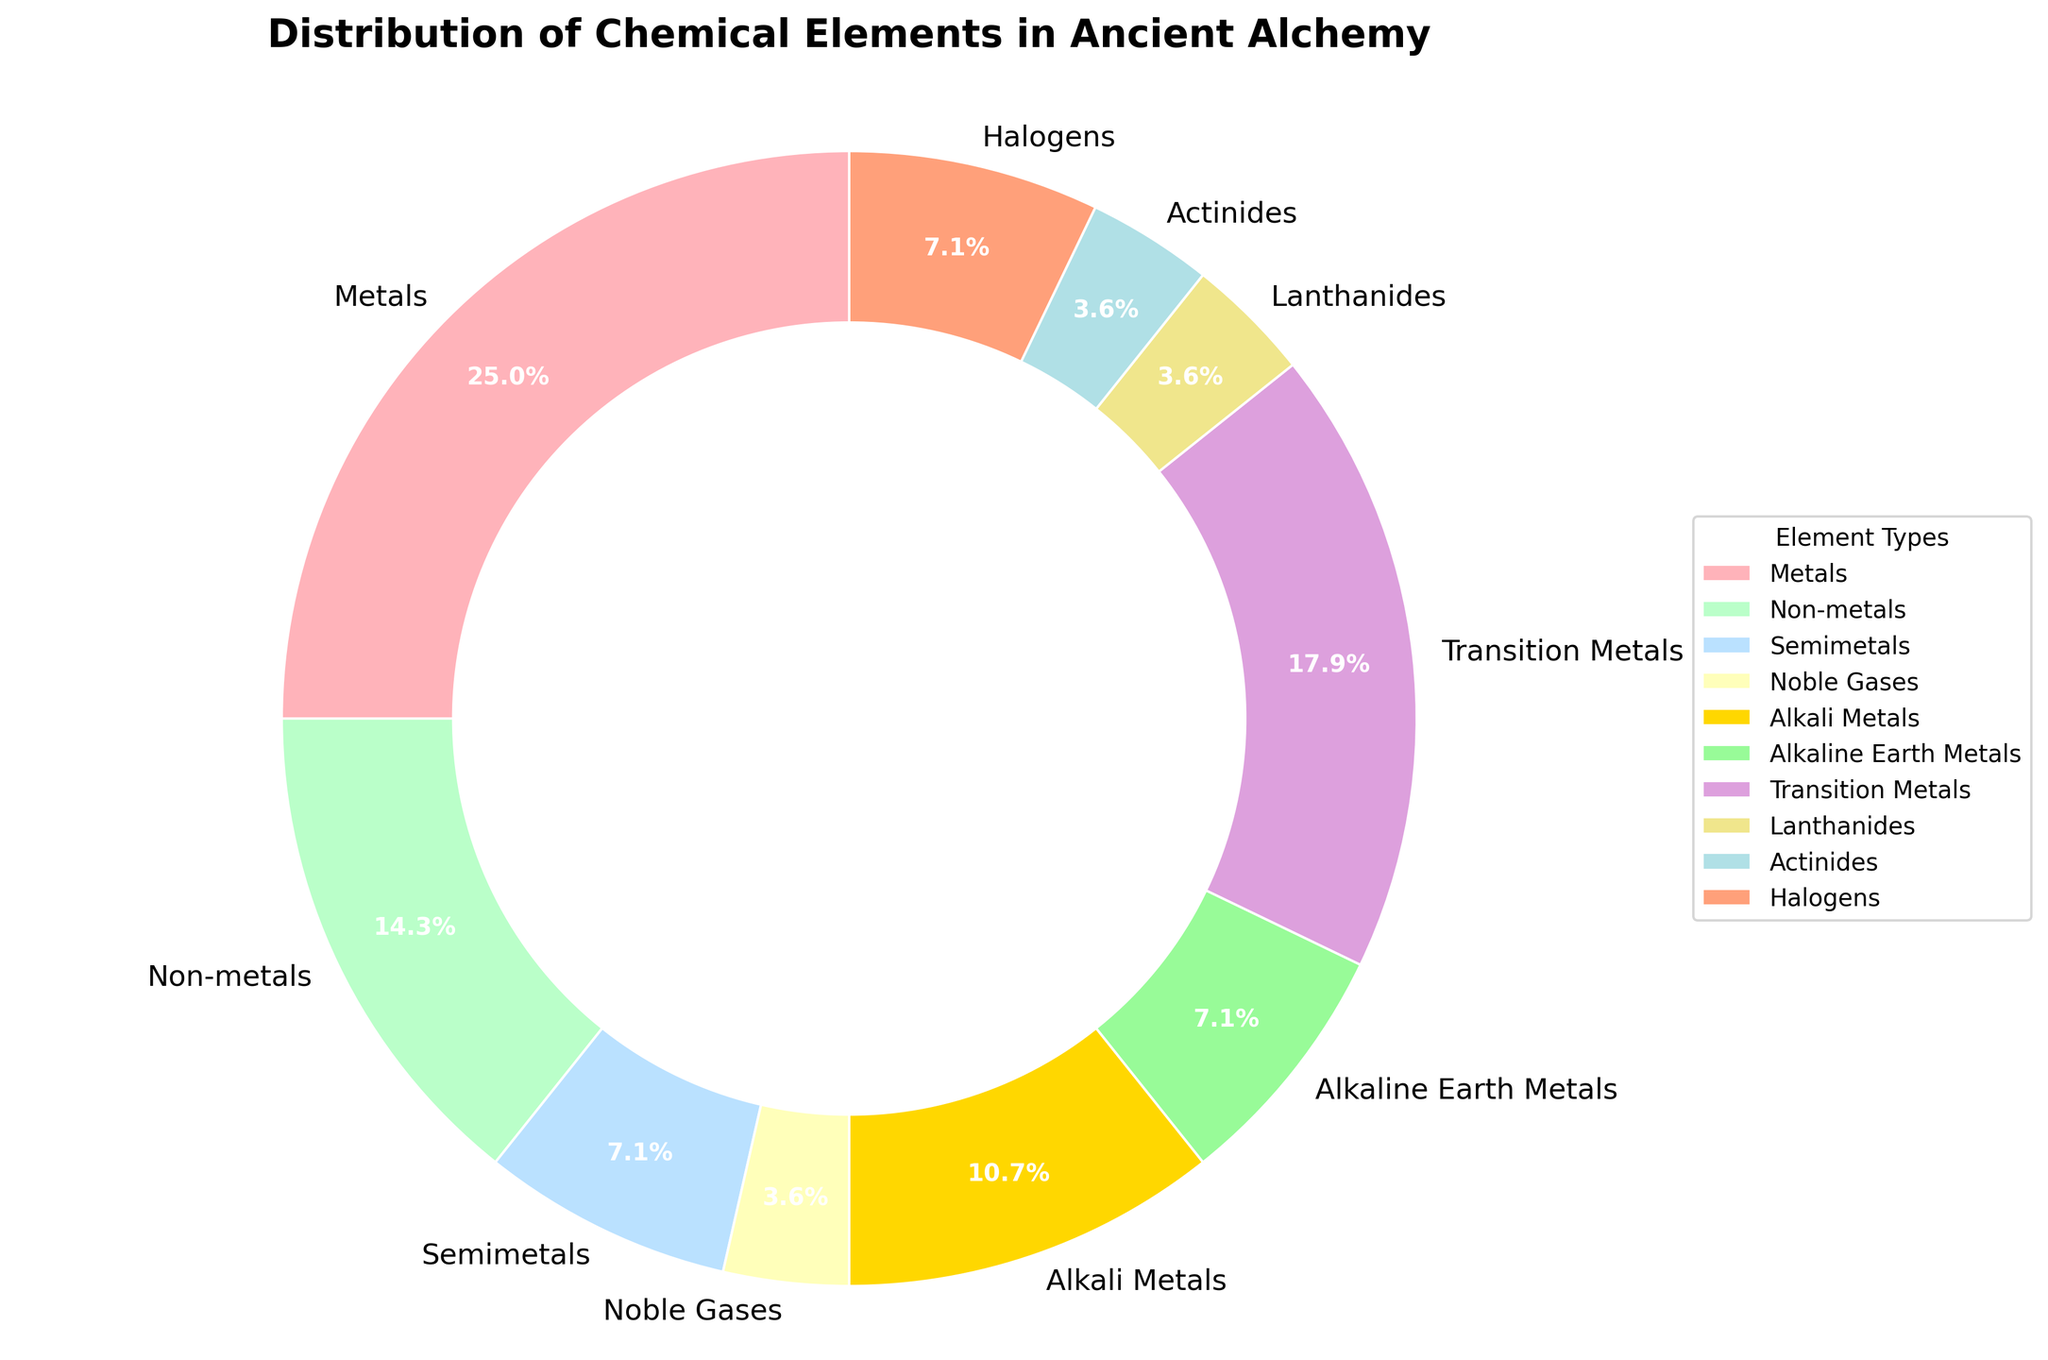Which element type has the highest count? By looking at the pie chart, you can see that the largest wedge represents the category with the highest count. In this case, it is the metals category.
Answer: Metals How many more metals are there compared to noble gases? From the pie chart, metals are represented with a count of 7, while noble gases are denoted with a count of 1. The difference is computed by subtracting 1 from 7.
Answer: 6 Which element types have the exact same count? You need to identify wedges of the same size on the pie chart. Semimetals and halogens both have a count of 2.
Answer: Semimetals and Halogens Which element type has the smallest proportional representation in the pie chart? The wedge with the smallest size or area represents the element type with the smallest count, which is noble gases.
Answer: Noble Gases What is the total count of elements used in ancient alchemy as represented in the pie chart? Sum up the counts from all wedges. This is calculated as 7 (Metals) + 4 (Non-metals) + 2 (Semimetals) + 1 (Noble Gases) + 3 (Alkali Metals) + 2 (Alkaline Earth Metals) + 5 (Transition Metals) + 1 (Lanthanides) + 1 (Actinides) + 2 (Halogens) = 28.
Answer: 28 What percentage of elements used in ancient alchemy are classified as transition metals? The wedge representing transition metals has a count of 5. To find the percentage, divide 5 by the total number of elements (28), then multiply by 100. \( (5/28) \times 100 \approx 17.9\% \)
Answer: 17.9% If you combined the counts of semimetals and actinides, would their sum be greater than that of alkali metals? Semimetals have a count of 2 and actinides have a count of 1. Their combined count is 2 + 1 = 3, which is equal to the count for alkali metals.
Answer: No What is the difference in element count between alkali metals and alkaline earth metals? Alkali metals have a count of 3, while alkaline earth metals have a count of 2. The difference is 3 - 2.
Answer: 1 Which two element types combined would give you the same count as transition metals? Transition metals have a count of 5. By combining the counts of non-metals (4) and noble gases (1), you get 4 + 1 = 5.
Answer: Non-metals and Noble Gases What proportion of the pie chart is made up of elements other than metals and transition metals? First, find the total count for metals and transition metals: 7 (Metals) + 5 (Transition Metals) = 12. Subtract this from the overall total count (28): 28 - 12 = 16. To find the proportion, divide 16 by 28, then multiply by 100. \( (16/28) \times 100 \approx 57.1\% \)
Answer: 57.1% 